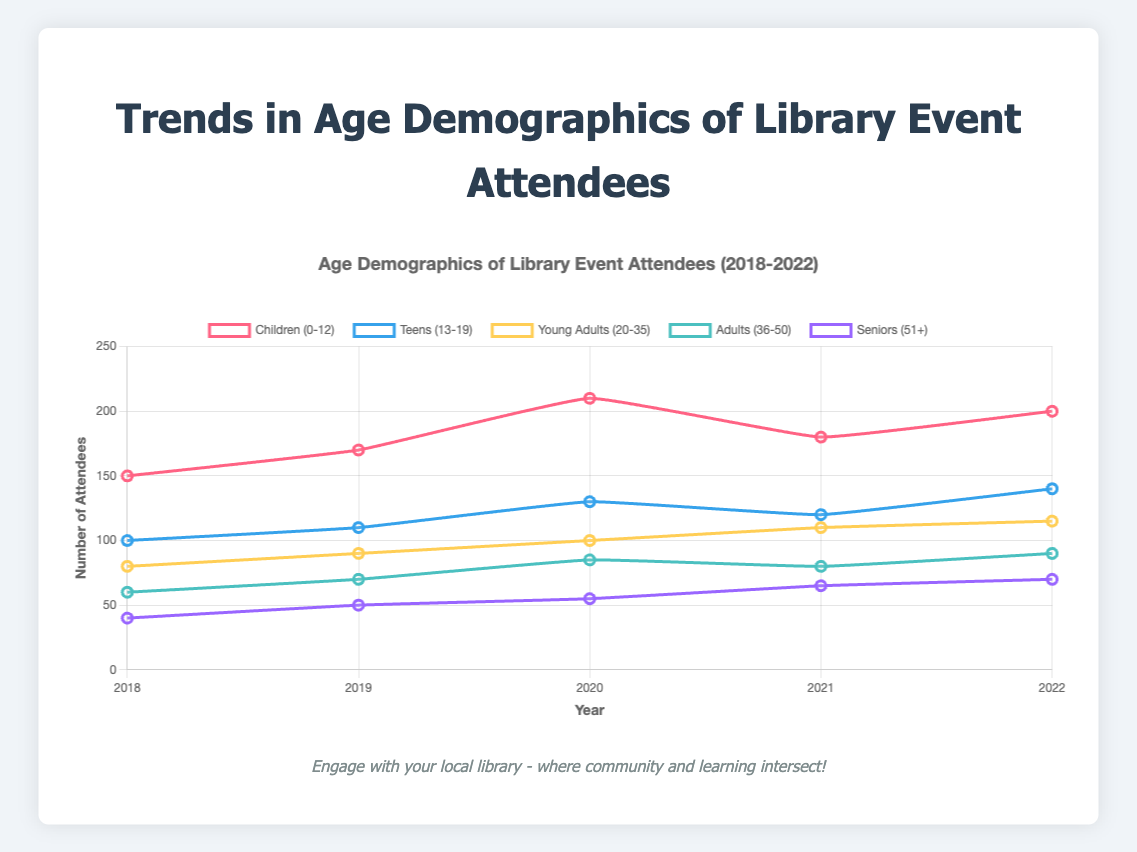What trend do you notice in the number of children attending library events from 2018 to 2022? The line for Children (0-12) shows an increase from 150 in 2018 to 210 in 2020, a slight drop to 180 in 2021, and then a rise to 200 in 2022. This overall trend indicates growth with a minor dip.
Answer: Increasing trend with a minor dip Which age group had the highest increase in event attendance from 2018 to 2022? Comparing all age groups, the Children (0-12) group increased from 150 to 200, gaining 50 attendees, the largest rise among the groups.
Answer: Children (0-12) Between 2018 and 2022, which group showed the most consistent increase in attendance each year? The Young Adults (20-35) group shows a steady annual increase from 80 to 115 without any dips or plateaus.
Answer: Young Adults (20-35) In 2021, which age group had the lowest number of attendees and how many attended? The lowest number of attendees in 2021 is seen in the Seniors (51+) group with 65 attendees.
Answer: Seniors (51+) with 65 attendees What was the combined total attendance of Teens (13-19) and Adults (36-50) in 2022? The Teens (13-19) had 140 attendees and the Adults (36-50) had 90 attendees in 2022. Summing them gives 140 + 90 = 230.
Answer: 230 attendees Compare the attendance of Seniors (51+) in 2018 versus 2022. What do you observe? The attendance for Seniors (51+) was 40 in 2018 and increased to 70 in 2022, showing a consistent rise.
Answer: Increased from 40 to 70 Which age group showed a drop in attendance in 2021 compared to 2020? The Children (0-12) group showed a drop from 210 attendees in 2020 to 180 in 2021.
Answer: Children (0-12) What is the sum of the attendees across all age groups in 2019? Summing the attendees for each group in 2019: Children (170) + Teens (110) + Young Adults (90) + Adults (70) + Seniors (50) = 490.
Answer: 490 Identify the age group that experienced the smallest increase in attendance from 2018 to 2022. The Young Adults (20-35) group increased from 80 to 115, a difference of 35, which is the smallest increase.
Answer: Young Adults (20-35) 